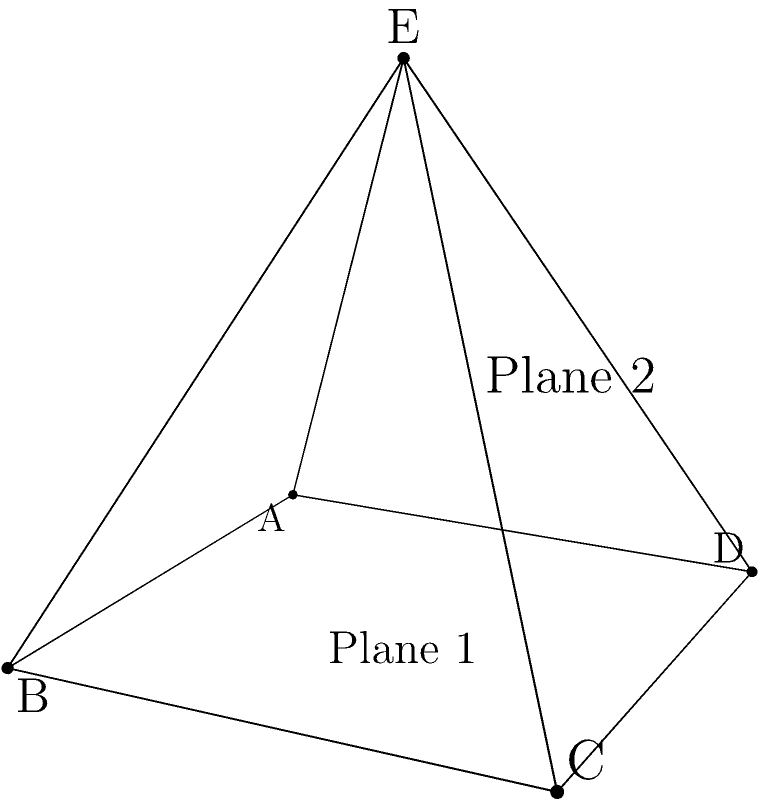In an origami-inspired costume element, a square base ABCD is folded to form a pyramid with apex E. The base is 2 units wide, and the height of the pyramid is 2 units. What is the angle between the plane ABE and the base plane ABCD? Let's approach this step-by-step:

1) First, we need to find the normal vectors of both planes.

2) For the base plane ABCD, the normal vector is simply $\vec{n_1} = (0, 0, 1)$.

3) For plane ABE, we need to find two vectors in the plane and take their cross product:
   $\vec{AB} = (2, 0, 0)$
   $\vec{AE} = (1, 1, 2)$
   
   $\vec{n_2} = \vec{AB} \times \vec{AE} = (2, -4, 2)$

4) The angle between the planes is the same as the angle between their normal vectors. We can find this using the dot product formula:

   $\cos \theta = \frac{\vec{n_1} \cdot \vec{n_2}}{|\vec{n_1}||\vec{n_2}|}$

5) Calculating:
   $\vec{n_1} \cdot \vec{n_2} = 2$
   $|\vec{n_1}| = 1$
   $|\vec{n_2}| = \sqrt{4 + 16 + 4} = \sqrt{24} = 2\sqrt{6}$

6) Substituting:
   $\cos \theta = \frac{2}{1 \cdot 2\sqrt{6}} = \frac{1}{\sqrt{6}}$

7) Therefore:
   $\theta = \arccos(\frac{1}{\sqrt{6}})$
Answer: $\arccos(\frac{1}{\sqrt{6}})$ radians or approximately 65.9° 